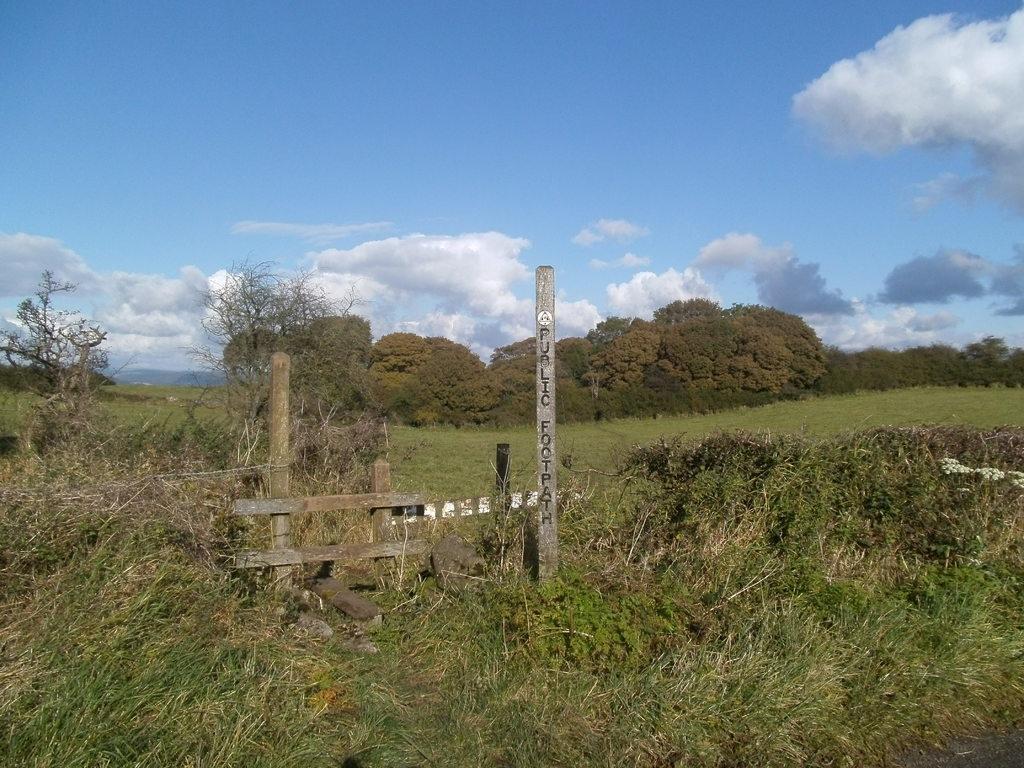Could you give a brief overview of what you see in this image? In this image we can see a pole with black color text. Image also consists of grass and also many trees. At the top there is sky with some clouds. 